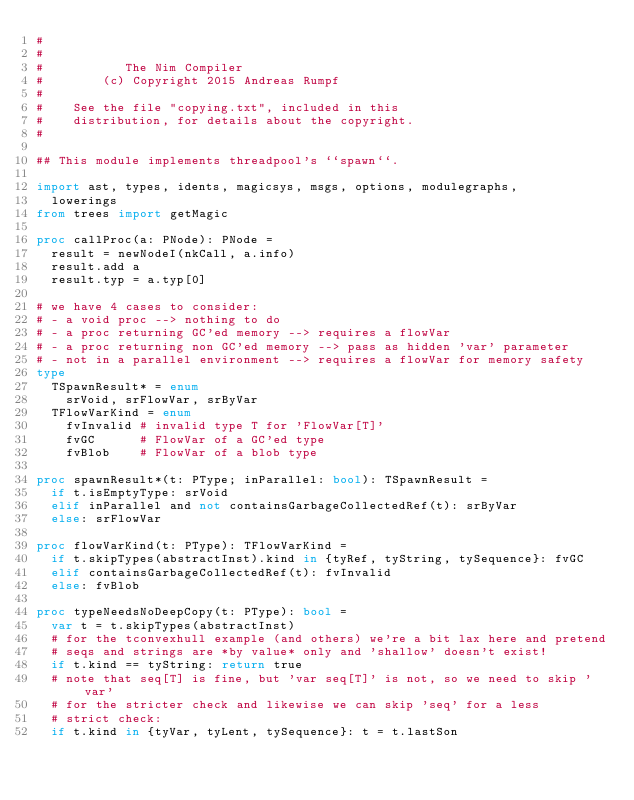<code> <loc_0><loc_0><loc_500><loc_500><_Nim_>#
#
#           The Nim Compiler
#        (c) Copyright 2015 Andreas Rumpf
#
#    See the file "copying.txt", included in this
#    distribution, for details about the copyright.
#

## This module implements threadpool's ``spawn``.

import ast, types, idents, magicsys, msgs, options, modulegraphs,
  lowerings
from trees import getMagic

proc callProc(a: PNode): PNode =
  result = newNodeI(nkCall, a.info)
  result.add a
  result.typ = a.typ[0]

# we have 4 cases to consider:
# - a void proc --> nothing to do
# - a proc returning GC'ed memory --> requires a flowVar
# - a proc returning non GC'ed memory --> pass as hidden 'var' parameter
# - not in a parallel environment --> requires a flowVar for memory safety
type
  TSpawnResult* = enum
    srVoid, srFlowVar, srByVar
  TFlowVarKind = enum
    fvInvalid # invalid type T for 'FlowVar[T]'
    fvGC      # FlowVar of a GC'ed type
    fvBlob    # FlowVar of a blob type

proc spawnResult*(t: PType; inParallel: bool): TSpawnResult =
  if t.isEmptyType: srVoid
  elif inParallel and not containsGarbageCollectedRef(t): srByVar
  else: srFlowVar

proc flowVarKind(t: PType): TFlowVarKind =
  if t.skipTypes(abstractInst).kind in {tyRef, tyString, tySequence}: fvGC
  elif containsGarbageCollectedRef(t): fvInvalid
  else: fvBlob

proc typeNeedsNoDeepCopy(t: PType): bool =
  var t = t.skipTypes(abstractInst)
  # for the tconvexhull example (and others) we're a bit lax here and pretend
  # seqs and strings are *by value* only and 'shallow' doesn't exist!
  if t.kind == tyString: return true
  # note that seq[T] is fine, but 'var seq[T]' is not, so we need to skip 'var'
  # for the stricter check and likewise we can skip 'seq' for a less
  # strict check:
  if t.kind in {tyVar, tyLent, tySequence}: t = t.lastSon</code> 